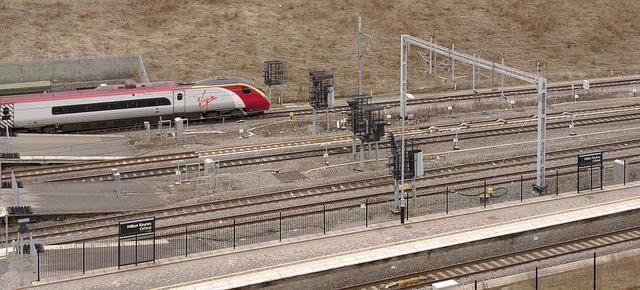What color is the train?
Keep it brief. Red. Are there fences there?
Answer briefly. Yes. Is the train in motion?
Keep it brief. No. 